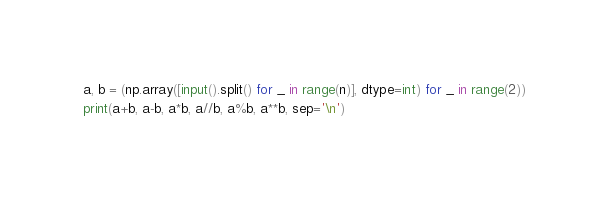Convert code to text. <code><loc_0><loc_0><loc_500><loc_500><_Python_>a, b = (np.array([input().split() for _ in range(n)], dtype=int) for _ in range(2))
print(a+b, a-b, a*b, a//b, a%b, a**b, sep='\n')</code> 